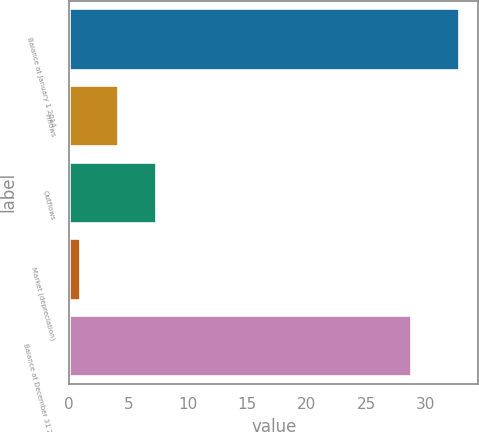<chart> <loc_0><loc_0><loc_500><loc_500><bar_chart><fcel>Balance at January 1 2014<fcel>Inflows<fcel>Outflows<fcel>Market (depreciation)<fcel>Balance at December 31 2014<nl><fcel>32.8<fcel>4.09<fcel>7.28<fcel>0.9<fcel>28.8<nl></chart> 